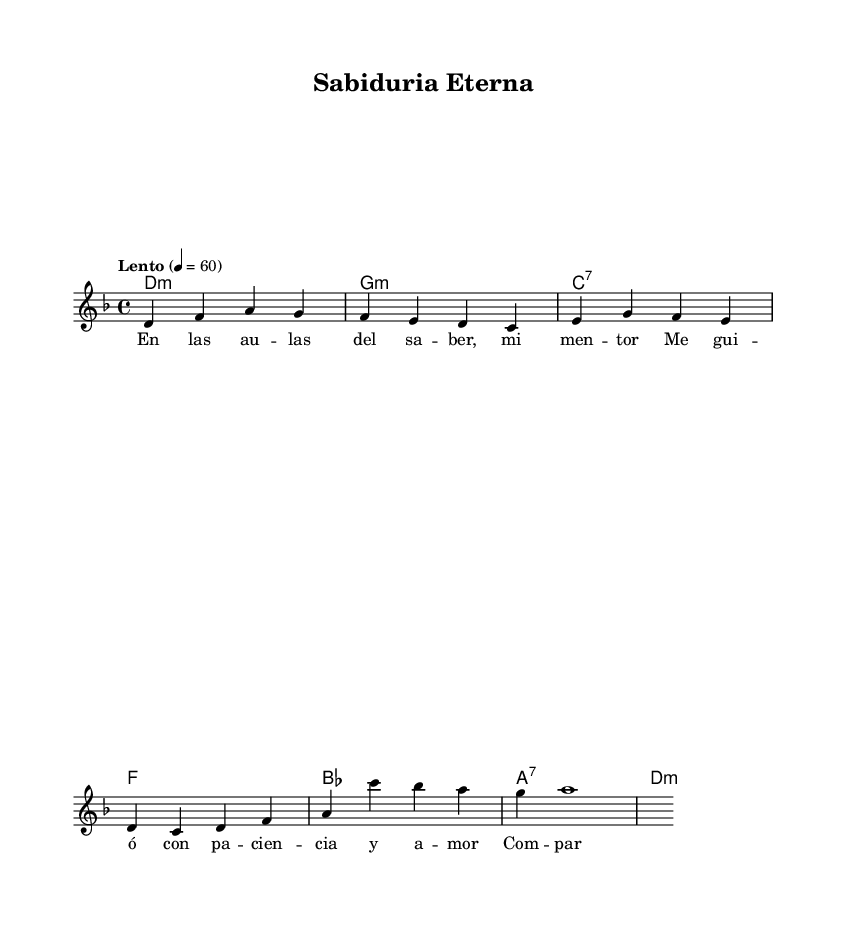What is the key signature of this music? The key signature is indicated at the beginning of the staff and shows two flats (B♭ and E♭), which means it is in D minor.
Answer: D minor What is the time signature? The time signature appears at the beginning of the score and is shown as 4/4, meaning there are four beats in a measure and a quarter note gets one beat.
Answer: 4/4 What is the tempo marking of the piece? The tempo marking is found at the beginning of the score, indicating the speed of the piece, which is "Lento," meaning slow. The number "60" specifies the beats per minute.
Answer: Lento What is the first note of the melody? The melody starts on the note D, which is the first pitch indicated in the melody line of the music.
Answer: D How many measures are there in the melody? The melody line contains a total of 8 distinct measures when counted, which can be seen from the rhythmic divisions in the sheet music.
Answer: 8 What is the last chord in the harmony section? The last chord shown in the harmony section is D minor, which is represented as "d:m" in the chord naming convention used in the sheet music.
Answer: D minor What theme is represented in the lyrics? The lyrics express the theme of mentorship and the wisdom shared during an academic journey, emphasizing patience and love in guidance.
Answer: Mentorship 